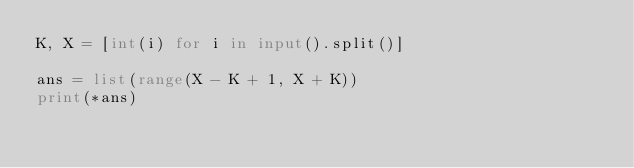<code> <loc_0><loc_0><loc_500><loc_500><_Python_>K, X = [int(i) for i in input().split()]

ans = list(range(X - K + 1, X + K))
print(*ans)</code> 